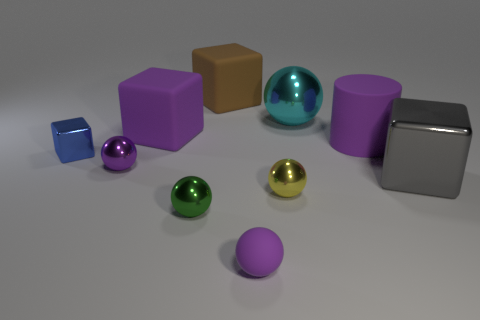Subtract all green spheres. How many spheres are left? 4 Subtract all big purple blocks. How many blocks are left? 3 Subtract all green spheres. Subtract all red blocks. How many spheres are left? 4 Subtract all blocks. How many objects are left? 6 Add 4 tiny blue things. How many tiny blue things are left? 5 Add 3 green metallic cubes. How many green metallic cubes exist? 3 Subtract 1 gray cubes. How many objects are left? 9 Subtract all purple cylinders. Subtract all blue metallic objects. How many objects are left? 8 